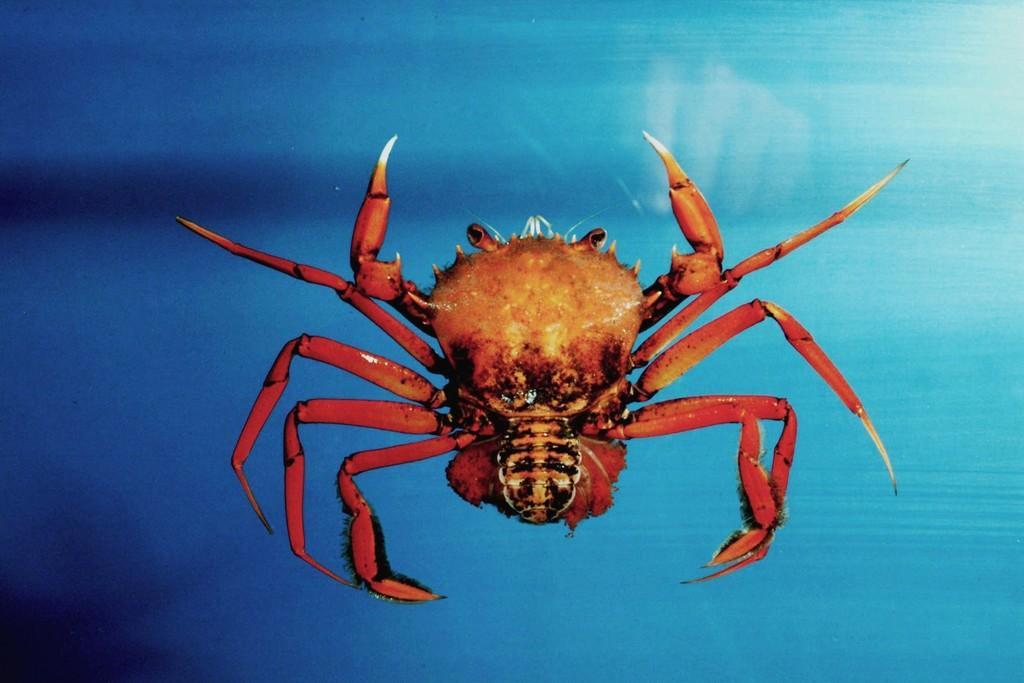Describe this image in one or two sentences. In this picture there is an insect in the center of the image. 